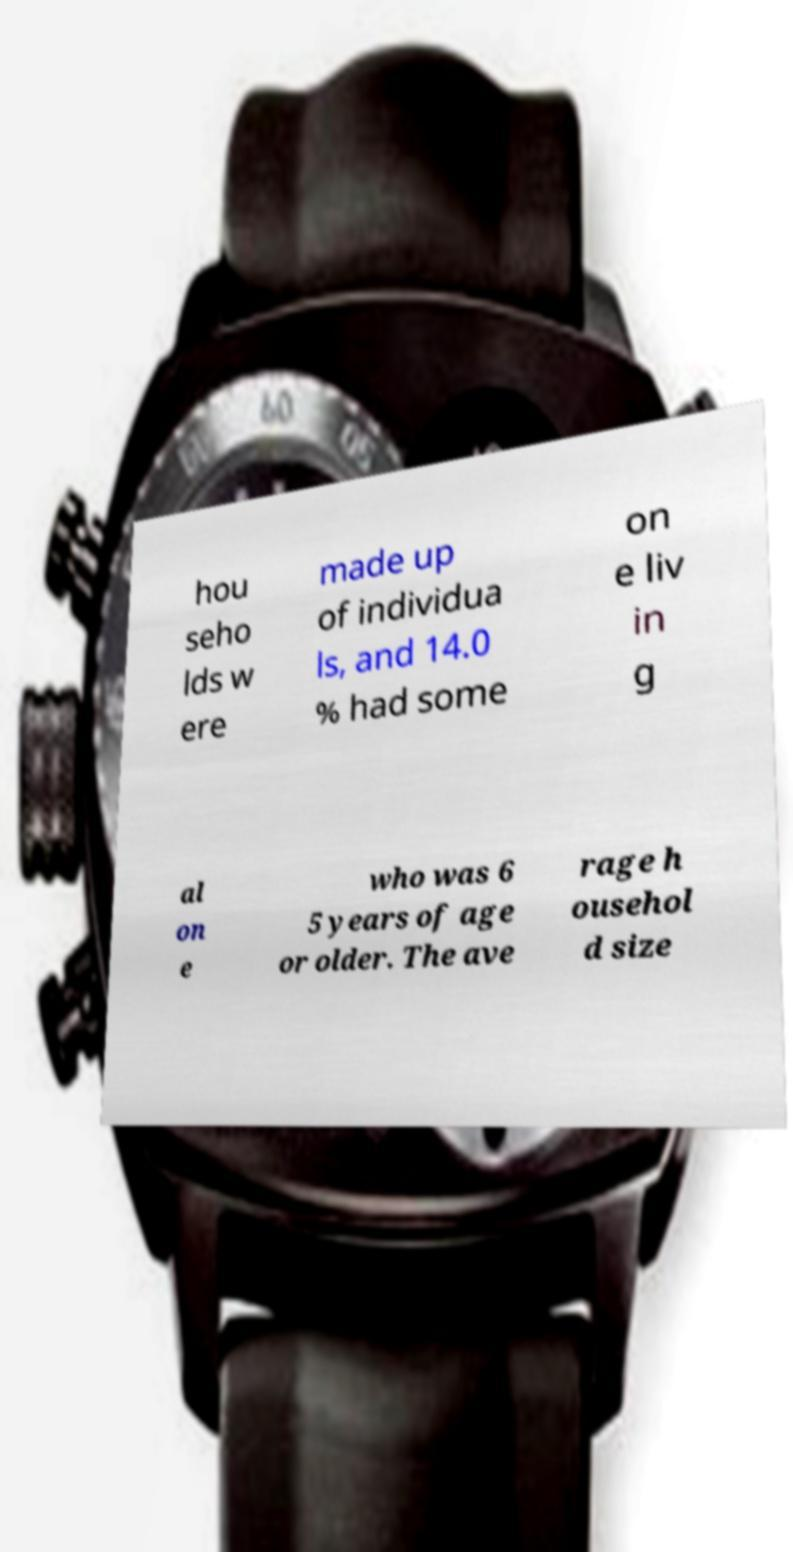Could you assist in decoding the text presented in this image and type it out clearly? hou seho lds w ere made up of individua ls, and 14.0 % had some on e liv in g al on e who was 6 5 years of age or older. The ave rage h ousehol d size 